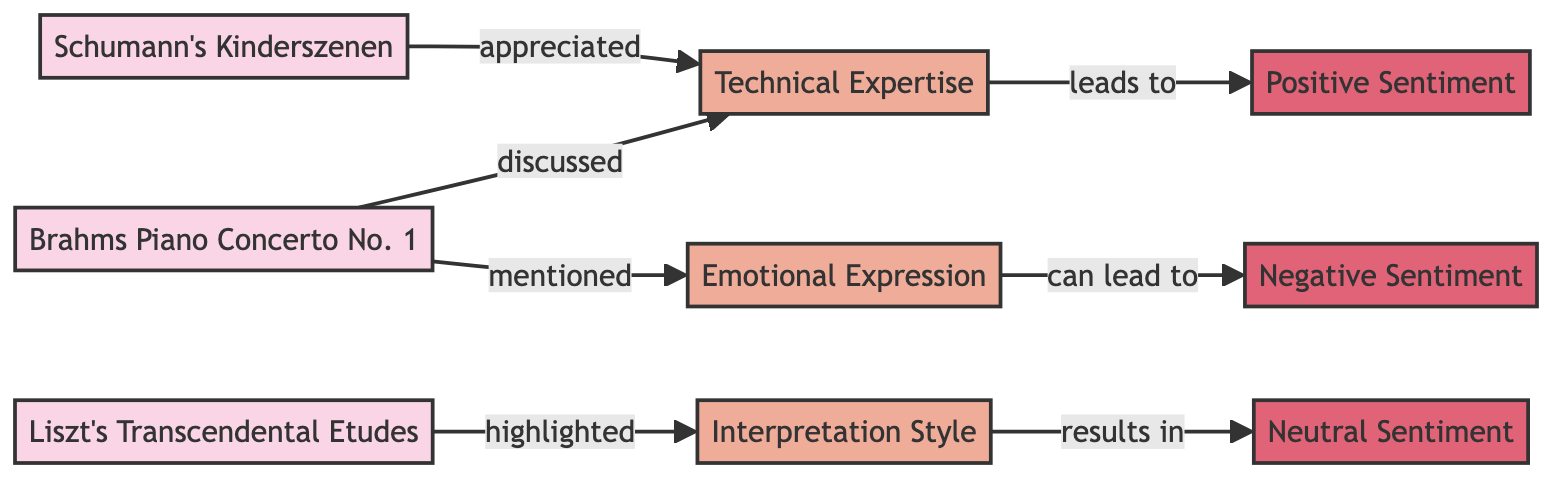What is the first performance piece listed in the diagram? The diagram lists three performance pieces: "Brahms Piano Concerto No. 1", "Liszt's Transcendental Etudes", and "Schumann's Kinderszenen". "Brahms Piano Concerto No. 1" is the first in the order they appear in the diagram.
Answer: Brahms Piano Concerto No. 1 How many themes are discussed in relation to the performance pieces? According to the diagram, there are three themes: "Technical Expertise", "Emotional Expression", and "Interpretation Style". This means that there are a total of three themes discussed.
Answer: 3 Which performance piece is associated with the theme "Interpretation Style"? The theme "Interpretation Style" is highlighted in relation to the performance piece "Liszt's Transcendental Etudes". The connection indicates that this specific theme is of focus in discussions about that piece.
Answer: Liszt's Transcendental Etudes What sentiment does "Technical Expertise" lead to? The diagram shows that the theme "Technical Expertise" leads to "Positive Sentiment", indicating that discussions around this theme tend to reflect a positive viewpoint.
Answer: Positive Sentiment Which performance piece has a theme that can lead to negative sentiment? The diagram indicates that the theme "Emotional Expression" can lead to "Negative Sentiment", but it is mentioned in connection with "Brahms Piano Concerto No. 1". Therefore, this performance piece is linked to the potential for negative sentiment through that theme.
Answer: Brahms Piano Concerto No. 1 Are there any negative sentiments linked to "Schumann's Kinderszenen"? The diagram does not show any negative sentiments linked to "Schumann's Kinderszenen". It is primarily associated with "Technical Expertise", which leads to positive sentiment, implying a lack of negative discussions about this performance piece.
Answer: No Which theme results in neutral sentiment? The theme "Interpretation Style" as highlighted in the diagram results in "Neutral Sentiment," suggesting that discussions around this theme do not lean towards a positive or negative sentiment, but rather remain neutral.
Answer: Interpretation Style How many connections are there between performance pieces and themes? The diagram illustrates three connections leading from performance pieces to themes: "Brahms Piano Concerto No. 1" to "Technical Expertise" and "Emotional Expression"; "Liszt's Transcendental Etudes" to "Interpretation Style"; and "Schumann's Kinderszenen" to "Technical Expertise." This totals four connections overall.
Answer: 4 